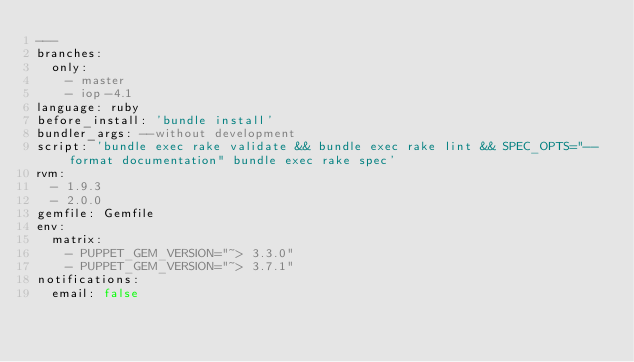Convert code to text. <code><loc_0><loc_0><loc_500><loc_500><_YAML_>---
branches:
  only:
    - master
    - iop-4.1
language: ruby
before_install: 'bundle install'
bundler_args: --without development
script: 'bundle exec rake validate && bundle exec rake lint && SPEC_OPTS="--format documentation" bundle exec rake spec'
rvm:
  - 1.9.3
  - 2.0.0
gemfile: Gemfile
env:
  matrix:
    - PUPPET_GEM_VERSION="~> 3.3.0"
    - PUPPET_GEM_VERSION="~> 3.7.1"
notifications:
  email: false
</code> 